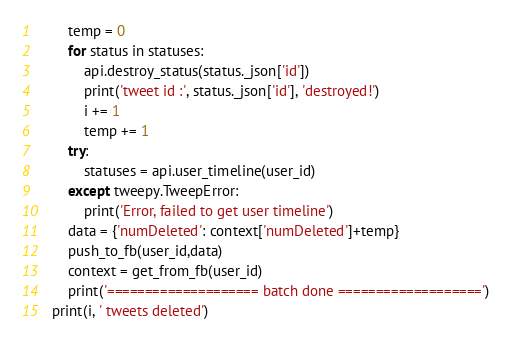Convert code to text. <code><loc_0><loc_0><loc_500><loc_500><_Python_>        temp = 0
        for status in statuses:
            api.destroy_status(status._json['id'])
            print('tweet id :', status._json['id'], 'destroyed!')
            i += 1
            temp += 1
        try:
            statuses = api.user_timeline(user_id)
        except tweepy.TweepError:
            print('Error, failed to get user timeline')
        data = {'numDeleted': context['numDeleted']+temp}
        push_to_fb(user_id,data)
        context = get_from_fb(user_id)
        print('==================== batch done ===================')
    print(i, ' tweets deleted')

</code> 